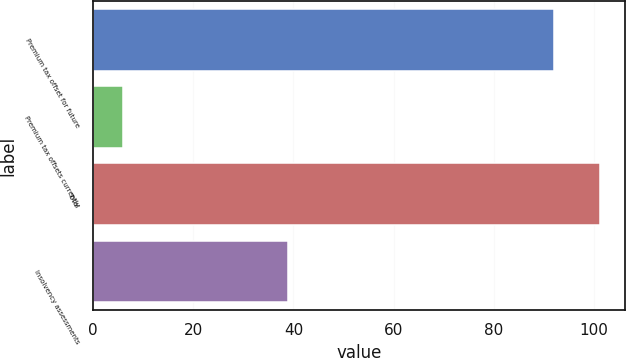Convert chart. <chart><loc_0><loc_0><loc_500><loc_500><bar_chart><fcel>Premium tax offset for future<fcel>Premium tax offsets currently<fcel>Total<fcel>Insolvency assessments<nl><fcel>92<fcel>6<fcel>101.2<fcel>39<nl></chart> 